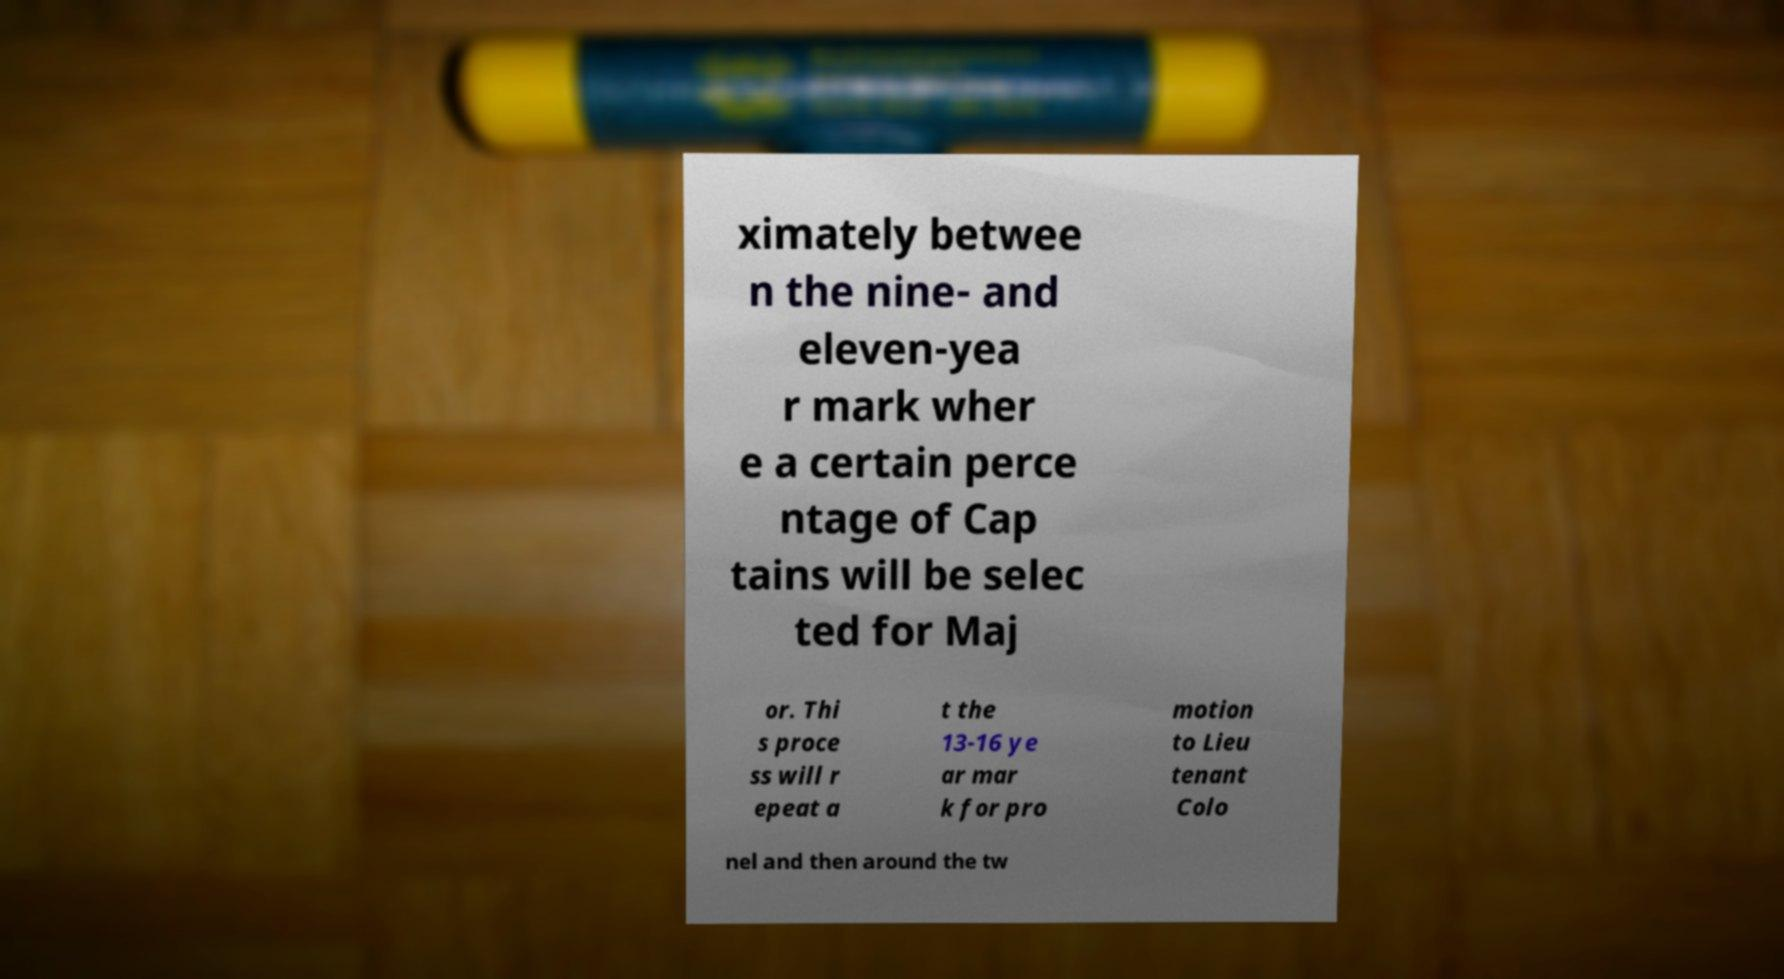Could you assist in decoding the text presented in this image and type it out clearly? ximately betwee n the nine- and eleven-yea r mark wher e a certain perce ntage of Cap tains will be selec ted for Maj or. Thi s proce ss will r epeat a t the 13-16 ye ar mar k for pro motion to Lieu tenant Colo nel and then around the tw 